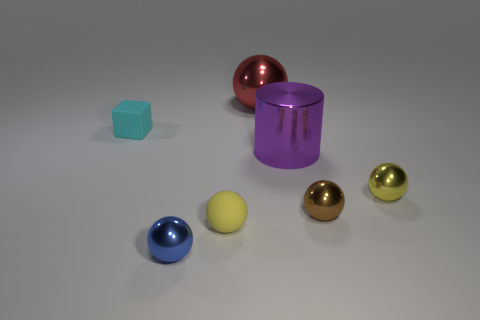What is the shape of the small brown object that is the same material as the tiny blue object?
Your answer should be compact. Sphere. Are there more tiny cyan objects right of the tiny yellow metallic object than big metal objects?
Give a very brief answer. No. What number of small rubber cubes are the same color as the shiny cylinder?
Give a very brief answer. 0. What number of other objects are there of the same color as the metal cylinder?
Offer a terse response. 0. Is the number of large green rubber objects greater than the number of tiny brown shiny balls?
Give a very brief answer. No. What is the material of the large purple cylinder?
Your response must be concise. Metal. Does the matte thing in front of the yellow shiny object have the same size as the shiny cylinder?
Your answer should be very brief. No. What size is the thing that is to the left of the blue ball?
Your answer should be compact. Small. Is there anything else that has the same material as the brown thing?
Offer a terse response. Yes. What number of small brown objects are there?
Offer a terse response. 1. 